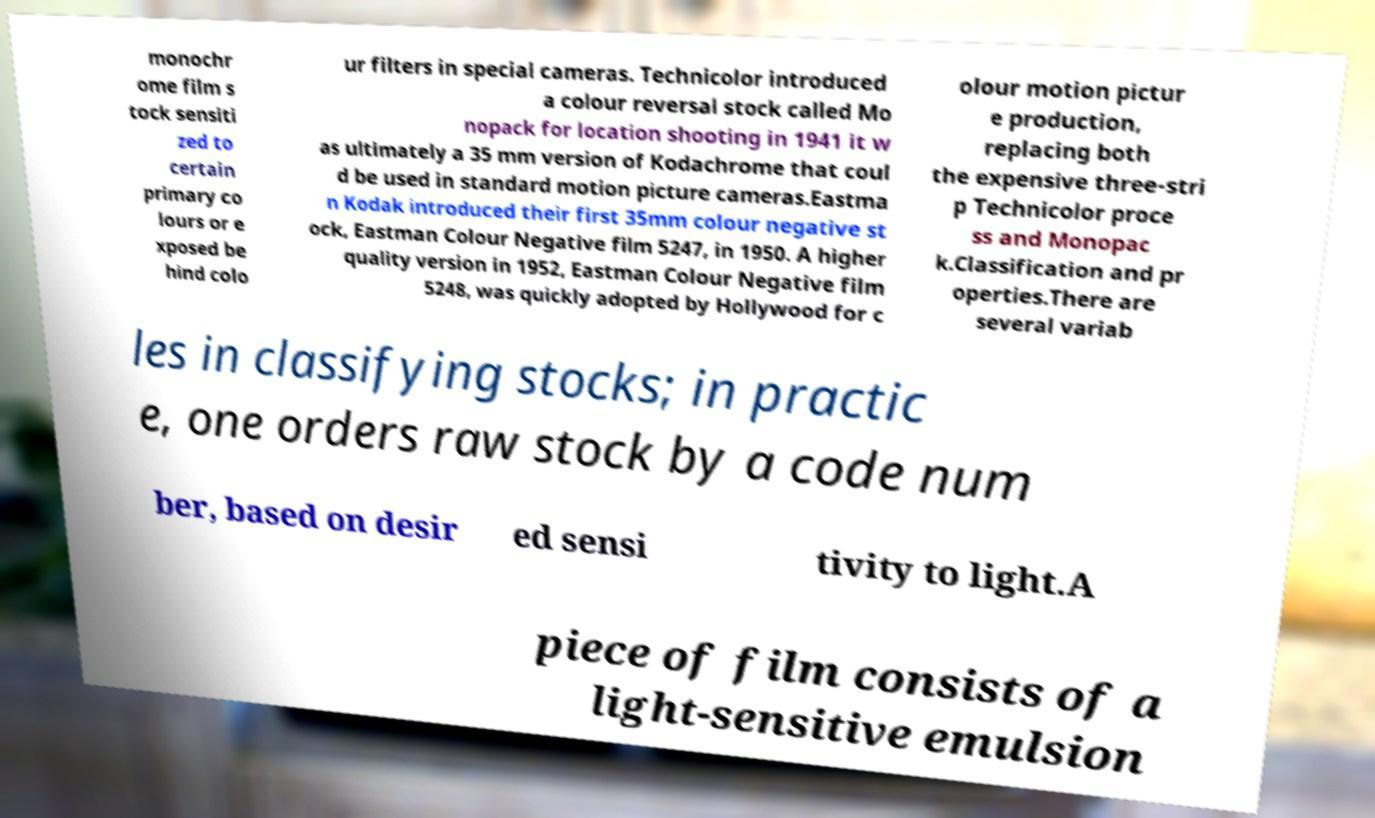Could you extract and type out the text from this image? monochr ome film s tock sensiti zed to certain primary co lours or e xposed be hind colo ur filters in special cameras. Technicolor introduced a colour reversal stock called Mo nopack for location shooting in 1941 it w as ultimately a 35 mm version of Kodachrome that coul d be used in standard motion picture cameras.Eastma n Kodak introduced their first 35mm colour negative st ock, Eastman Colour Negative film 5247, in 1950. A higher quality version in 1952, Eastman Colour Negative film 5248, was quickly adopted by Hollywood for c olour motion pictur e production, replacing both the expensive three-stri p Technicolor proce ss and Monopac k.Classification and pr operties.There are several variab les in classifying stocks; in practic e, one orders raw stock by a code num ber, based on desir ed sensi tivity to light.A piece of film consists of a light-sensitive emulsion 